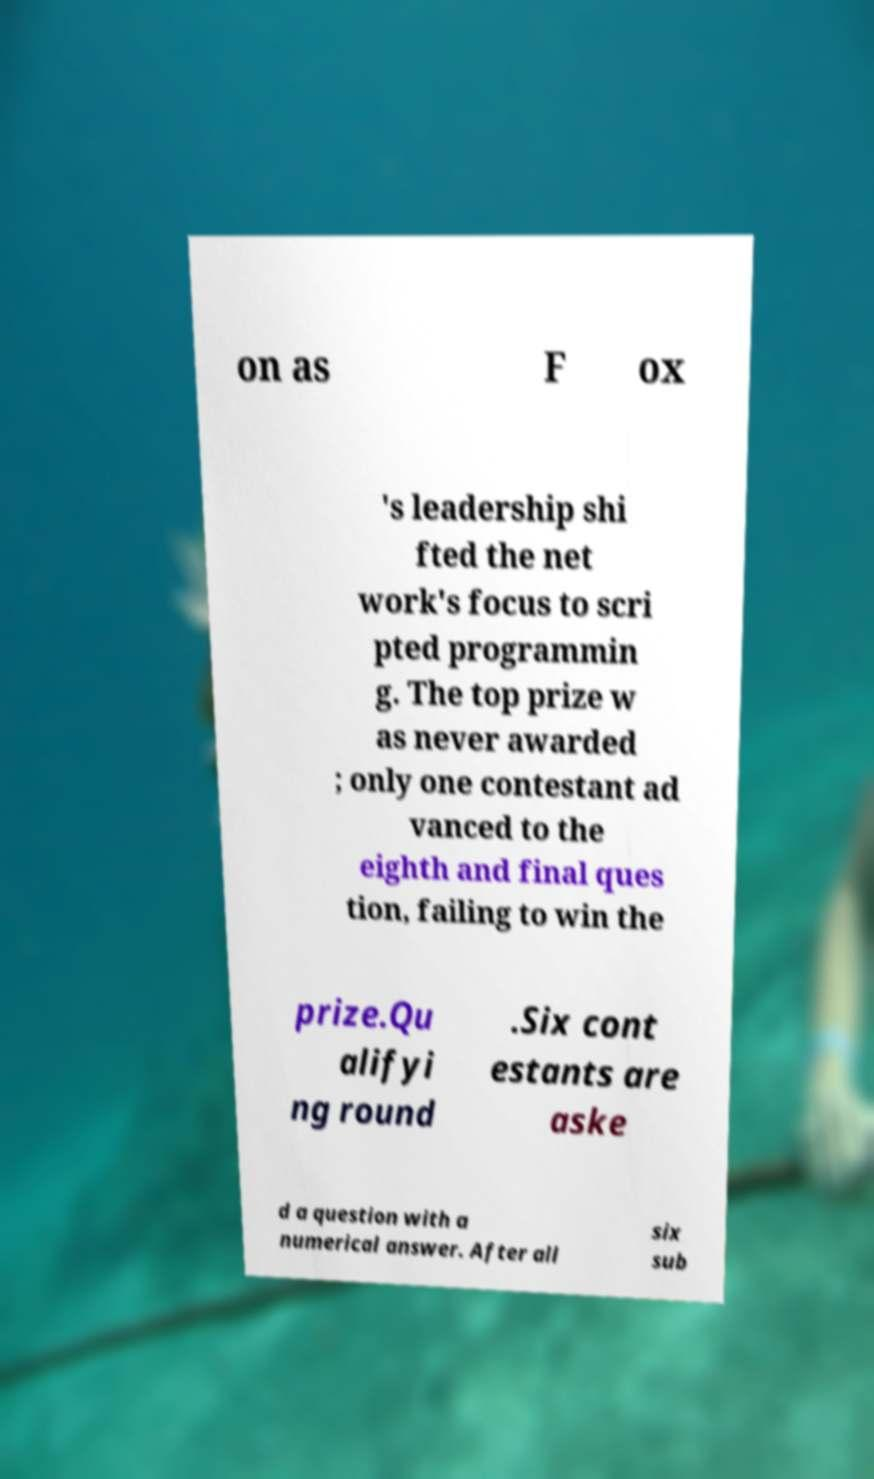Could you extract and type out the text from this image? on as F ox 's leadership shi fted the net work's focus to scri pted programmin g. The top prize w as never awarded ; only one contestant ad vanced to the eighth and final ques tion, failing to win the prize.Qu alifyi ng round .Six cont estants are aske d a question with a numerical answer. After all six sub 